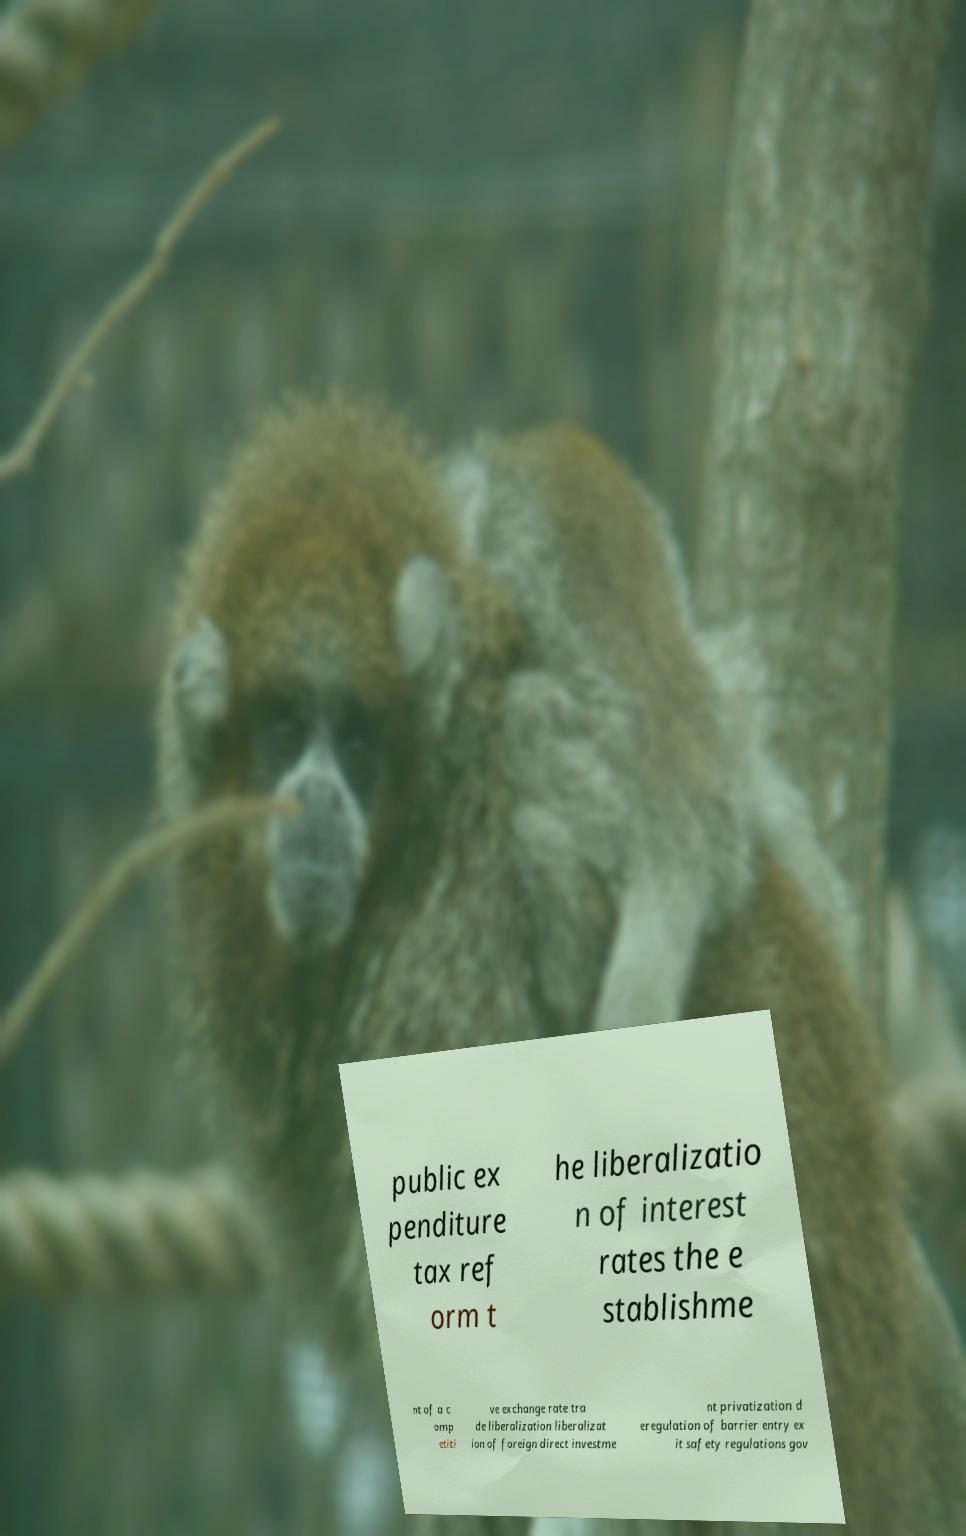Please read and relay the text visible in this image. What does it say? public ex penditure tax ref orm t he liberalizatio n of interest rates the e stablishme nt of a c omp etiti ve exchange rate tra de liberalization liberalizat ion of foreign direct investme nt privatization d eregulation of barrier entry ex it safety regulations gov 